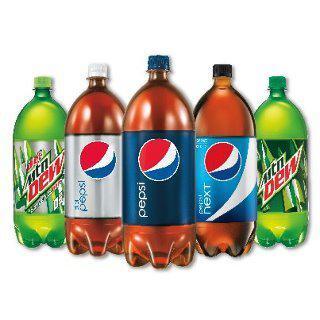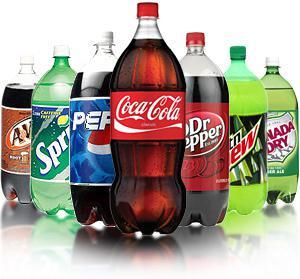The first image is the image on the left, the second image is the image on the right. Considering the images on both sides, is "The left image contains two non-overlapping bottles, and the right image contains three non-overlapping bottles." valid? Answer yes or no. No. The first image is the image on the left, the second image is the image on the right. Given the left and right images, does the statement "There are five soda bottles in total." hold true? Answer yes or no. No. 